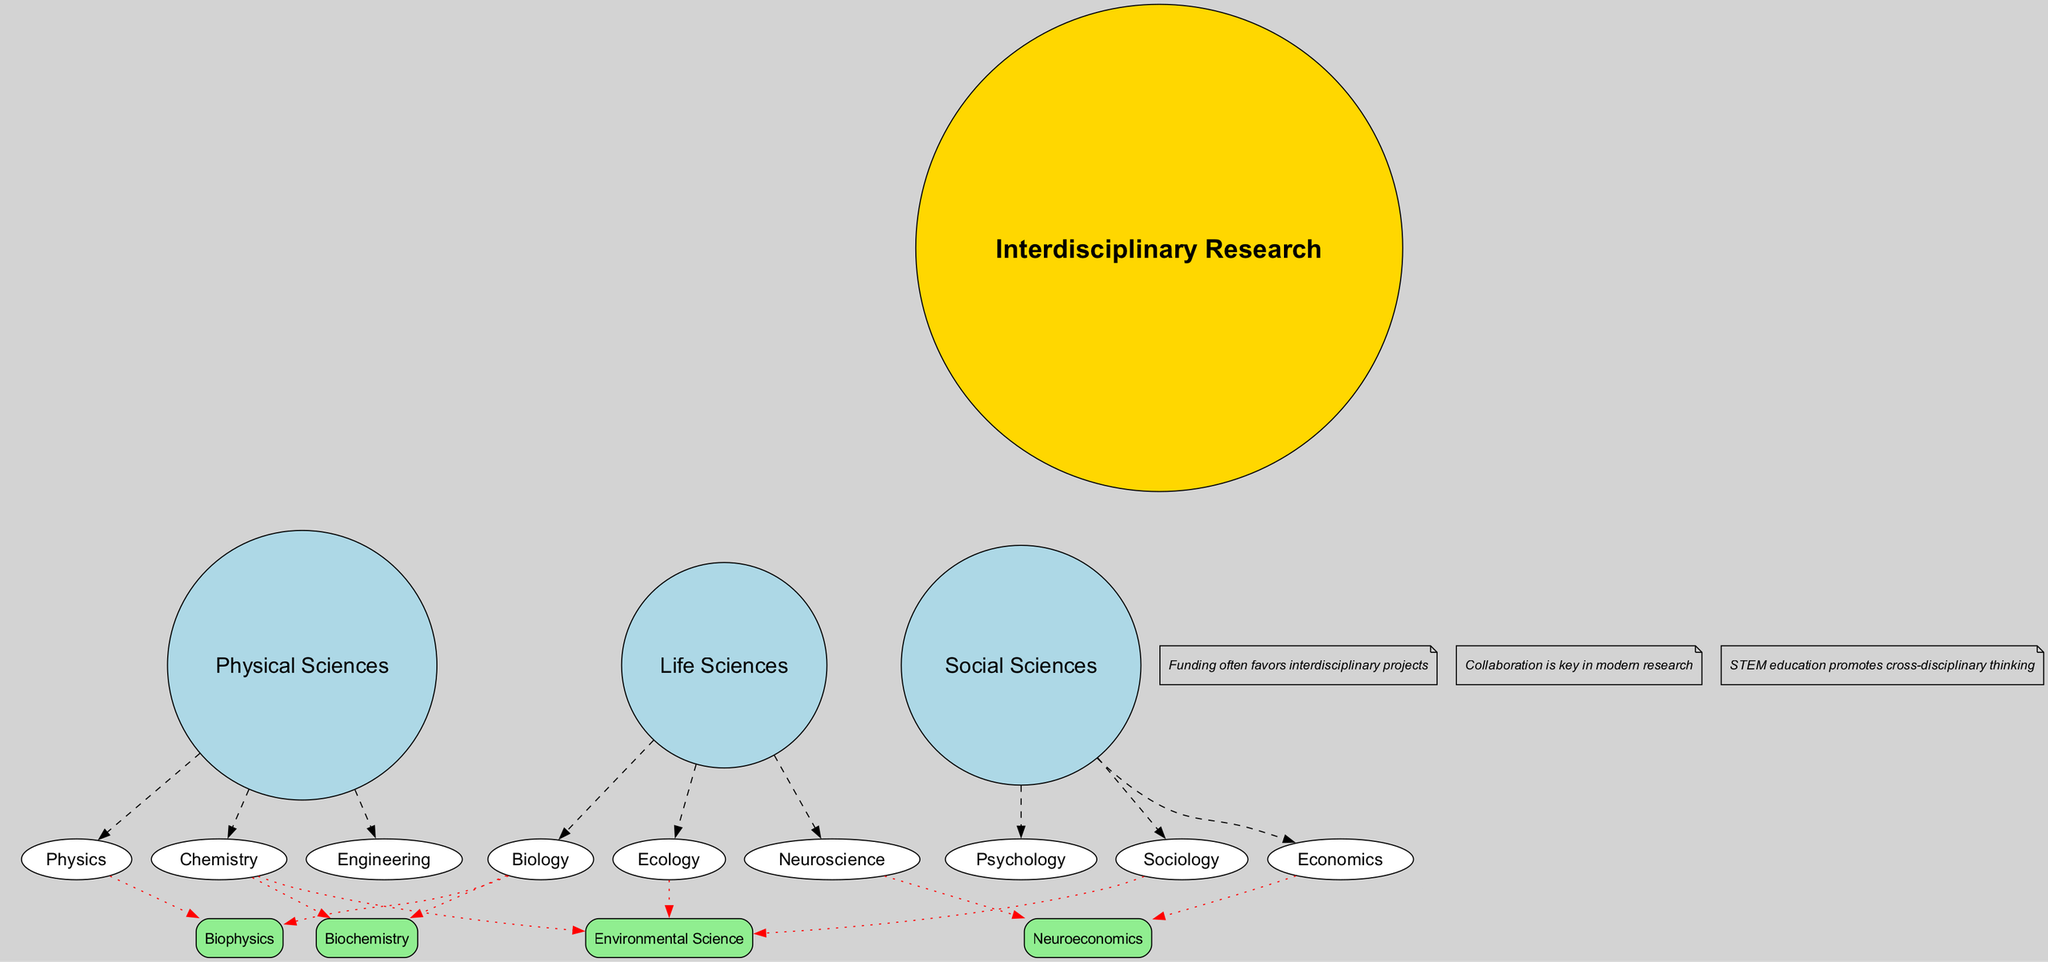What is at the center of the diagram? The center of the Venn diagram represents the concept of "Interdisciplinary Research," which is designed to showcase the importance of collaboration across different scientific fields. This is a basic descriptive question focusing on a prominent feature of the diagram.
Answer: Interdisciplinary Research How many main scientific circles are represented in the diagram? The diagram displays three main scientific circles: Physical Sciences, Life Sciences, and Social Sciences. This is a straightforward count of the main areas reflected in the Venn diagram.
Answer: 3 What is the intersection of Physics and Biology called? The diagram illustrates the intersection of Physics and Biology as "Biophysics." This requires identifying the specific intersection labeled among the other intersections in the Venn diagram.
Answer: Biophysics Which sub-circle lies under Life Sciences? The sub-circles under Life Sciences include Biology, Ecology, and Neuroscience. As this question pertains to the Life Sciences section, any of these sub-disciplines would suffice, as they are all directly represented underneath this main circle.
Answer: Biology (or Ecology or Neuroscience) How many intersections are there in the diagram? The diagram includes four distinct intersections representing interdisciplinary fields: Biophysics, Biochemistry, Neuroeconomics, and Environmental Science. This requires a count of the labeled intersections within the depicted Venn structure.
Answer: 4 What does collaboration signify in modern research according to the notes? The diagram notes emphasize that collaboration is essential in modern research, suggesting that working together across different scientific disciplines enhances the depth and quality of scientific inquiry. This requires reasoning around the importance presented in the notes section of the diagram.
Answer: Key Which sub-circle is shared between Chemistry, Biology, and Sociology? Environmental Science is the intersection labeled among Chemistry, Ecology, and Sociology in the Venn diagram, showcasing how these fields overlap in addressing environmental issues. It requires recognizing the specific intersection label and the associated fields.
Answer: Environmental Science What funding trend does the diagram suggest? According to the notes in the diagram, funding typically favors interdisciplinary projects, highlighting a financial support trend aimed at research that bridges multiple scientific fields. This captures the essence of the diagram's commentary on science funding.
Answer: Favors What are the three main categories of sciences depicted? The three main categories illustrated in the Venn diagram are Physical Sciences, Life Sciences, and Social Sciences. This question is focused on recalling the primary divisions indicated in the diagram.
Answer: Physical Sciences, Life Sciences, Social Sciences 